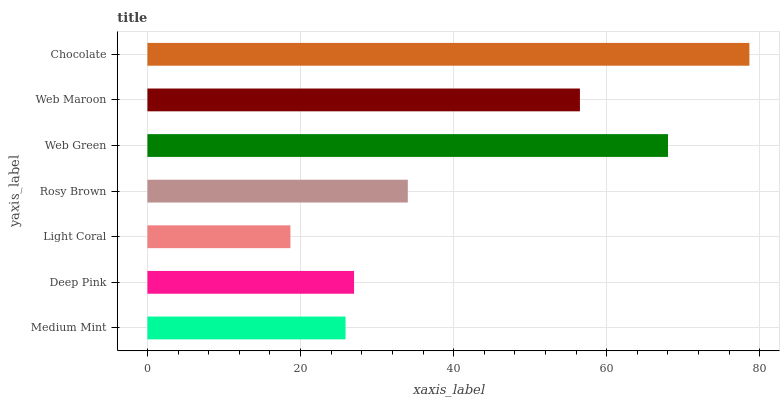Is Light Coral the minimum?
Answer yes or no. Yes. Is Chocolate the maximum?
Answer yes or no. Yes. Is Deep Pink the minimum?
Answer yes or no. No. Is Deep Pink the maximum?
Answer yes or no. No. Is Deep Pink greater than Medium Mint?
Answer yes or no. Yes. Is Medium Mint less than Deep Pink?
Answer yes or no. Yes. Is Medium Mint greater than Deep Pink?
Answer yes or no. No. Is Deep Pink less than Medium Mint?
Answer yes or no. No. Is Rosy Brown the high median?
Answer yes or no. Yes. Is Rosy Brown the low median?
Answer yes or no. Yes. Is Web Maroon the high median?
Answer yes or no. No. Is Web Green the low median?
Answer yes or no. No. 